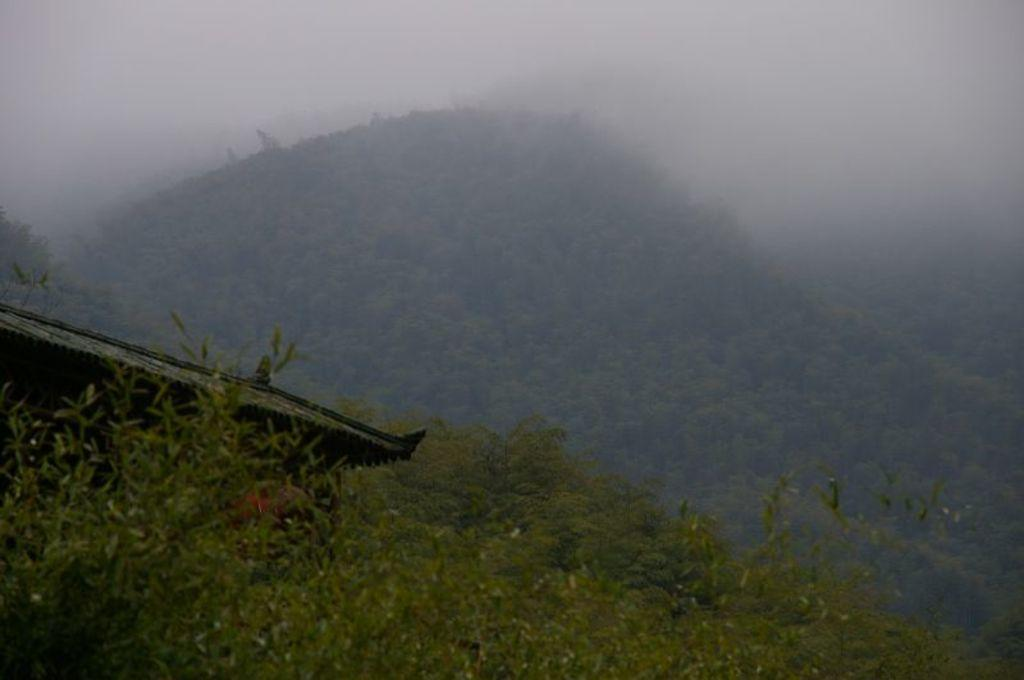What type of natural landform can be seen in the image? There are mountains in the image. What type of vegetation is present in the image? There are trees in the image. What type of man-made structure is visible in the image? There is a house in the image. What colors are used to depict the sky in the image? The sky is in white and blue color in the image. Can you see any fangs on the trees in the image? There are no fangs present on the trees in the image, as trees do not have fangs. How many tomatoes are growing on the mountains in the image? There are no tomatoes visible in the image, as it features mountains, trees, a house, and a sky with white and blue colors. 